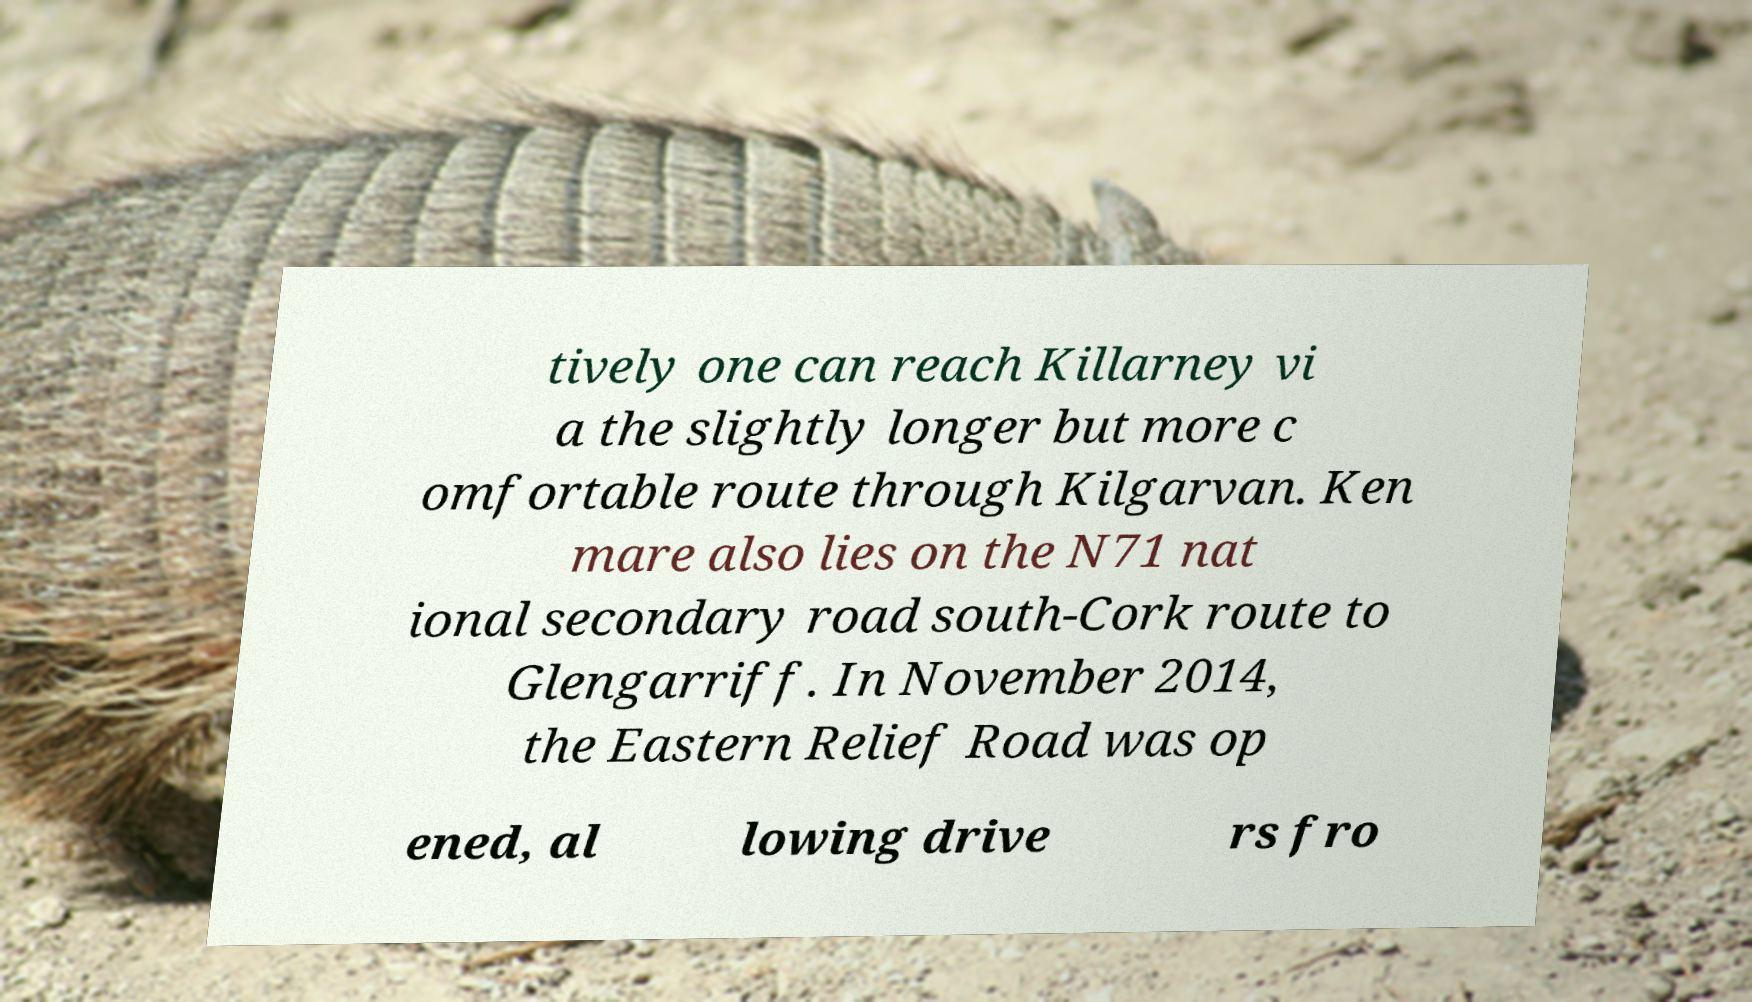Can you accurately transcribe the text from the provided image for me? tively one can reach Killarney vi a the slightly longer but more c omfortable route through Kilgarvan. Ken mare also lies on the N71 nat ional secondary road south-Cork route to Glengarriff. In November 2014, the Eastern Relief Road was op ened, al lowing drive rs fro 